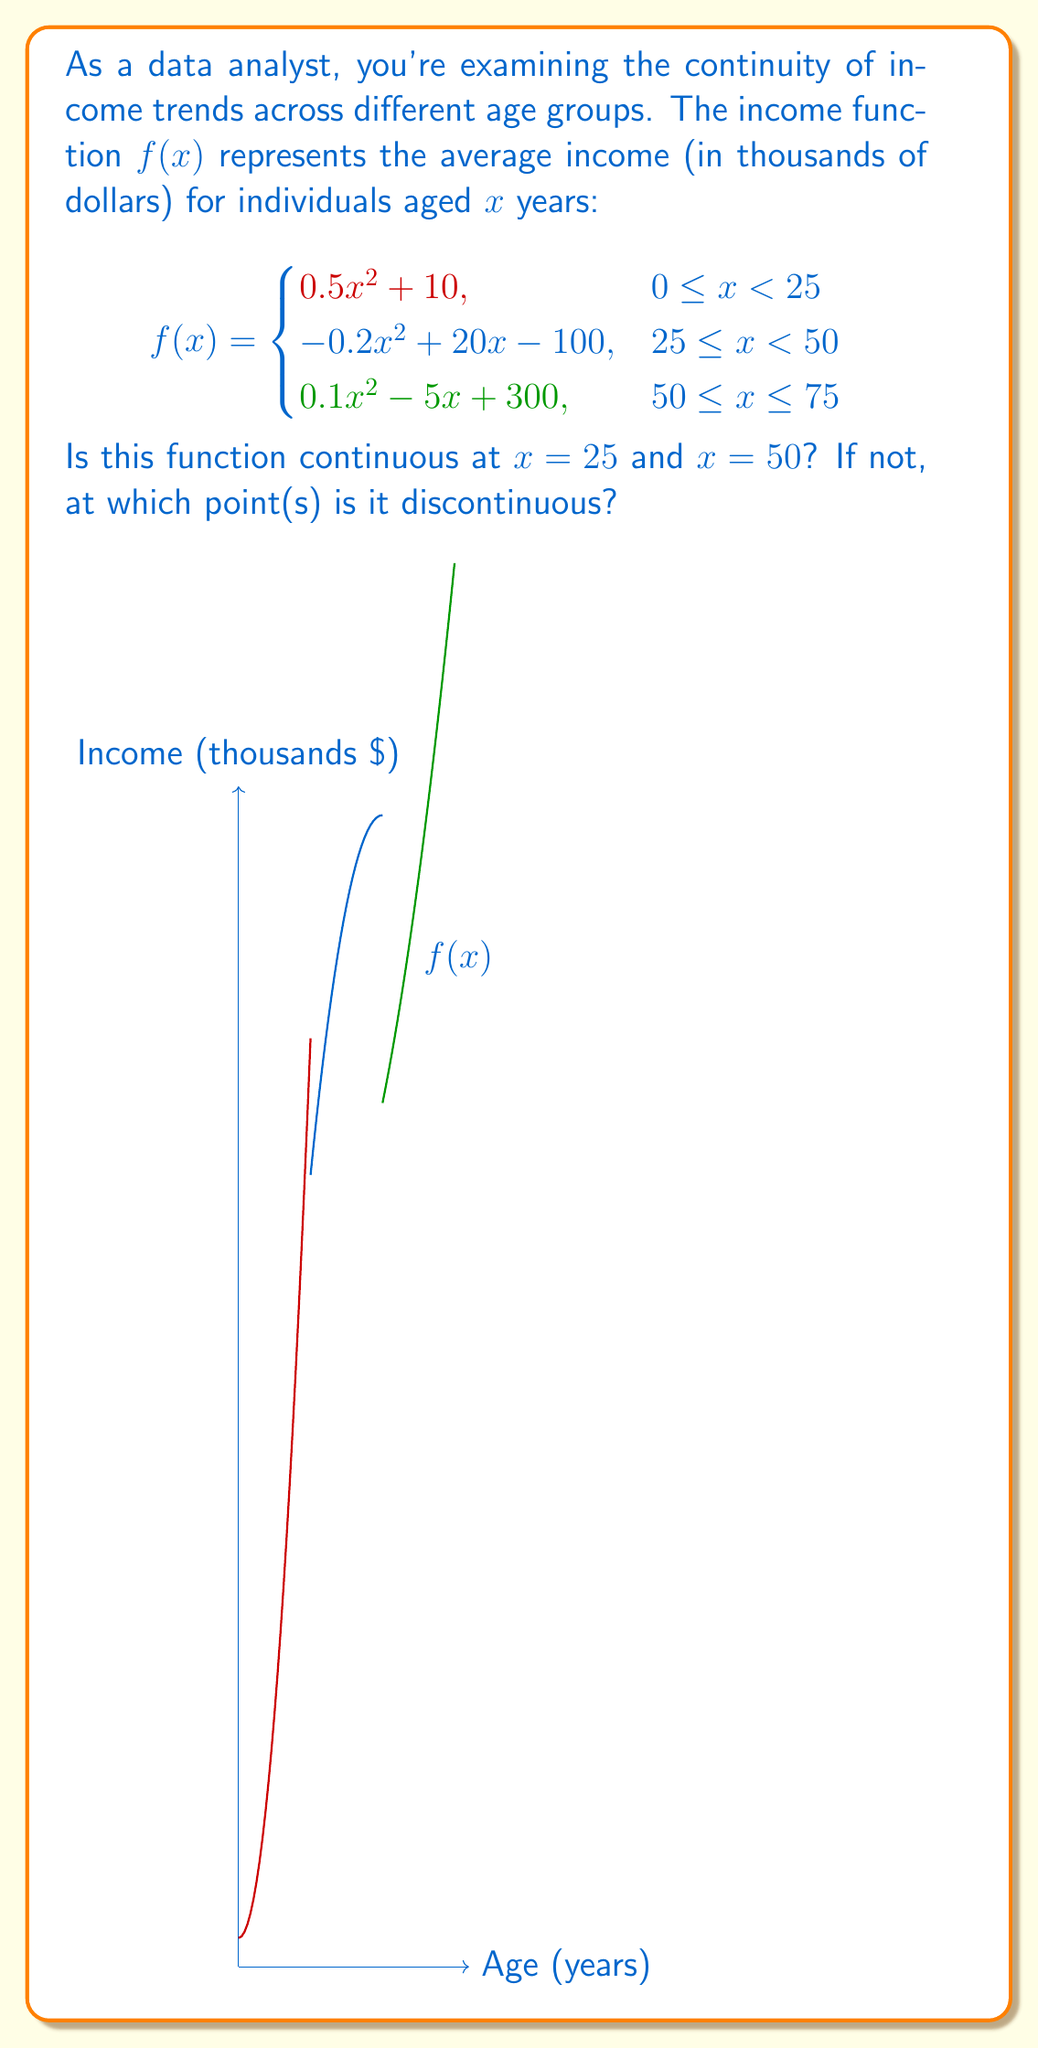Show me your answer to this math problem. To determine if the function is continuous at $x = 25$ and $x = 50$, we need to check three conditions at each point:
1. The function is defined at the point.
2. The limit of the function exists as we approach the point from both sides.
3. The limit equals the function value at that point.

For $x = 25$:

1. $f(25)$ is defined for both pieces of the function.
2. Left limit: 
   $\lim_{x \to 25^-} f(x) = 0.5(25)^2 + 10 = 322.5$
   Right limit: 
   $\lim_{x \to 25^+} f(x) = -0.2(25)^2 + 20(25) - 100 = 275$
3. The left and right limits are not equal, so the limit doesn't exist at $x = 25$.

Therefore, the function is discontinuous at $x = 25$.

For $x = 50$:

1. $f(50)$ is defined for both pieces of the function.
2. Left limit: 
   $\lim_{x \to 50^-} f(x) = -0.2(50)^2 + 20(50) - 100 = 400$
   Right limit: 
   $\lim_{x \to 50^+} f(x) = 0.1(50)^2 - 5(50) + 300 = 300$
3. The left and right limits are not equal, so the limit doesn't exist at $x = 50$.

Therefore, the function is discontinuous at $x = 50$.
Answer: Discontinuous at $x = 25$ and $x = 50$ 